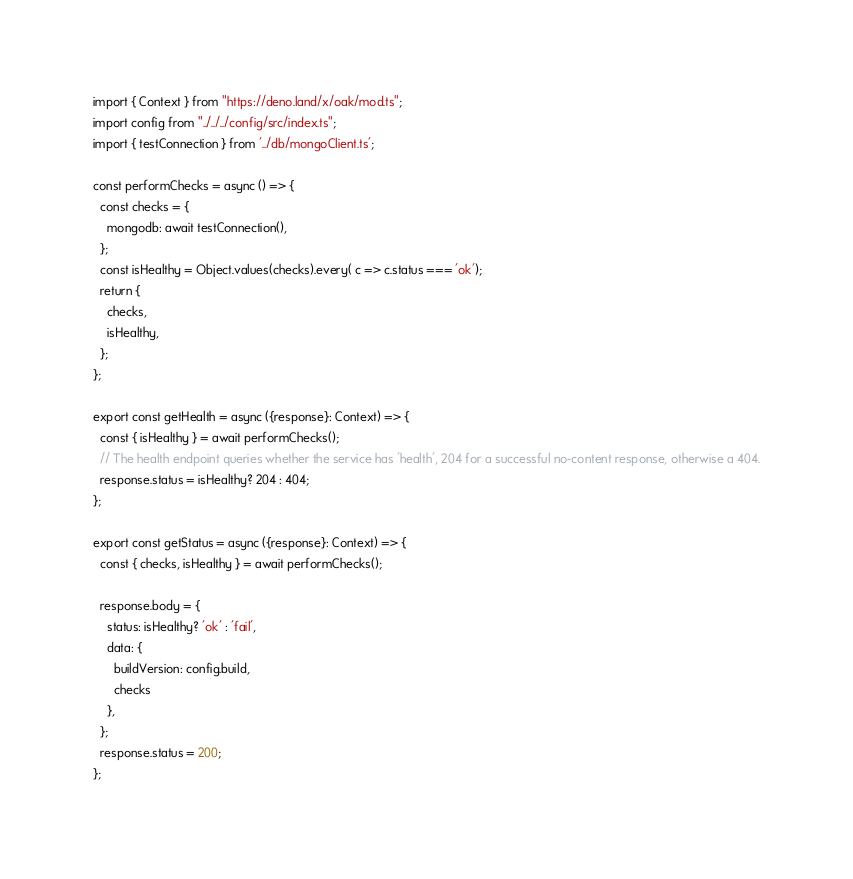Convert code to text. <code><loc_0><loc_0><loc_500><loc_500><_TypeScript_>import { Context } from "https://deno.land/x/oak/mod.ts";
import config from "../../../config/src/index.ts";
import { testConnection } from '../db/mongoClient.ts';

const performChecks = async () => {
  const checks = {
    mongodb: await testConnection(),
  };
  const isHealthy = Object.values(checks).every( c => c.status === 'ok');
  return {
    checks,
    isHealthy,
  };
};

export const getHealth = async ({response}: Context) => {
  const { isHealthy } = await performChecks();
  // The health endpoint queries whether the service has 'health', 204 for a successful no-content response, otherwise a 404.
  response.status = isHealthy? 204 : 404;
};

export const getStatus = async ({response}: Context) => {
  const { checks, isHealthy } = await performChecks();

  response.body = {
    status: isHealthy? 'ok' : 'fail',
    data: {
      buildVersion: config.build,
      checks
    },
  };
  response.status = 200;
};
</code> 